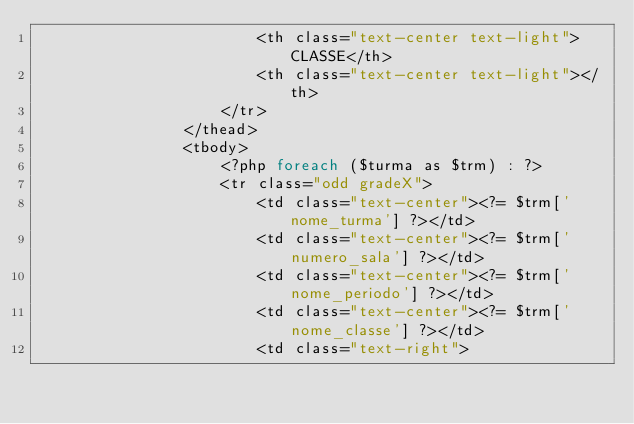Convert code to text. <code><loc_0><loc_0><loc_500><loc_500><_PHP_>                        <th class="text-center text-light">CLASSE</th>
                        <th class="text-center text-light"></th>
                    </tr>
                </thead>
                <tbody>
                    <?php foreach ($turma as $trm) : ?>
                    <tr class="odd gradeX">
                        <td class="text-center"><?= $trm['nome_turma'] ?></td>
                        <td class="text-center"><?= $trm['numero_sala'] ?></td>
                        <td class="text-center"><?= $trm['nome_periodo'] ?></td>
                        <td class="text-center"><?= $trm['nome_classe'] ?></td>
                        <td class="text-right"></code> 